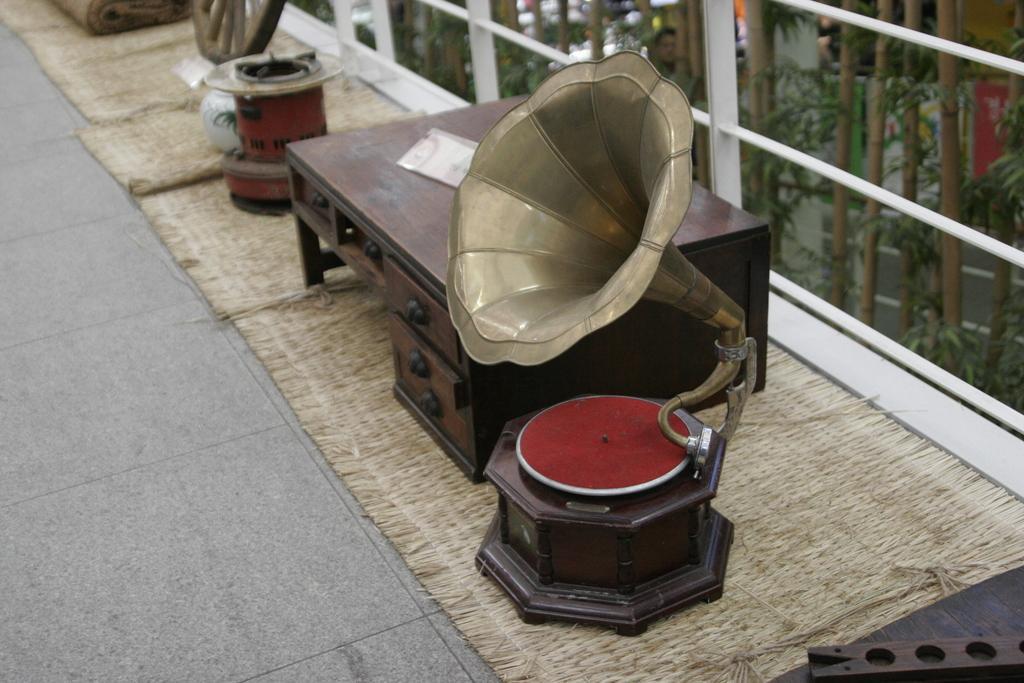How would you summarize this image in a sentence or two? In this image, we can see a wooden table, there is a musical instrument. We can see some glass windows. 